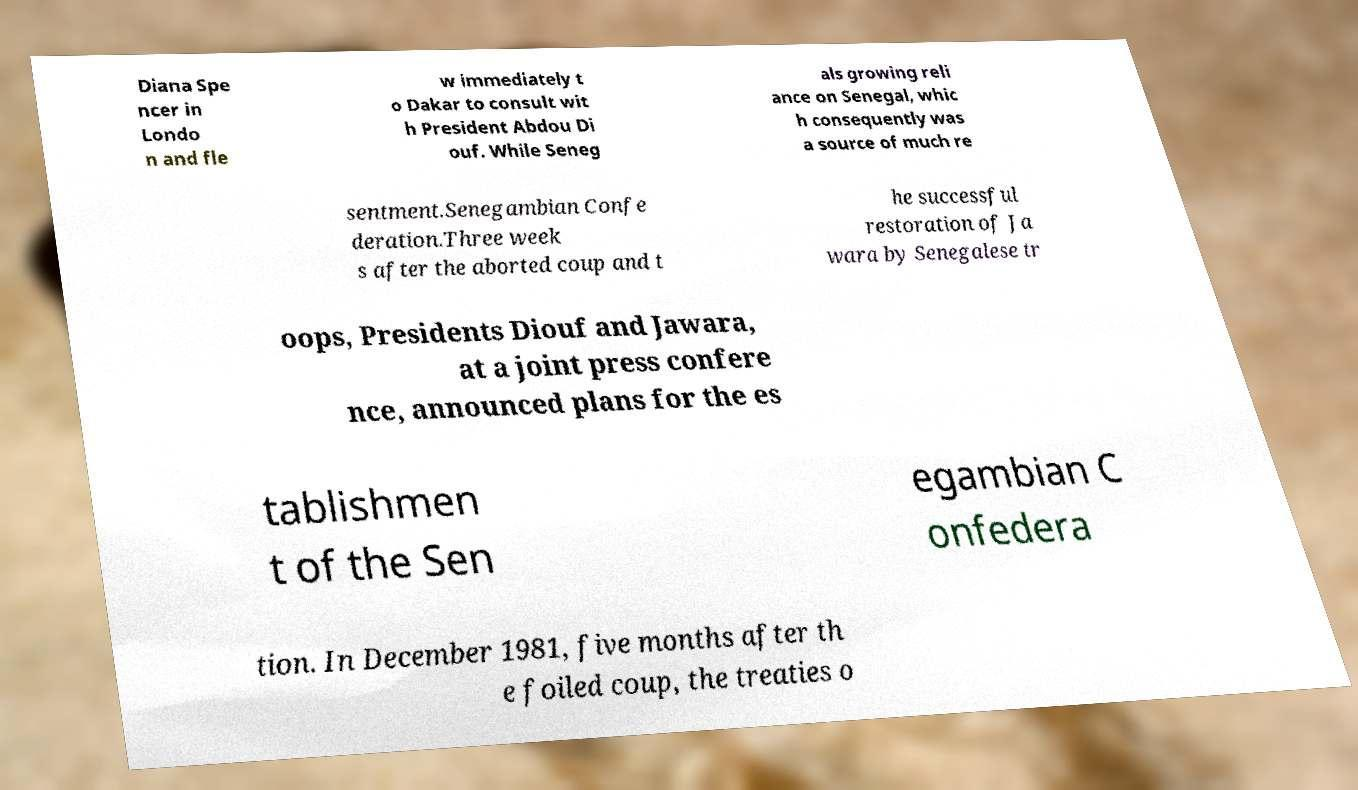For documentation purposes, I need the text within this image transcribed. Could you provide that? Diana Spe ncer in Londo n and fle w immediately t o Dakar to consult wit h President Abdou Di ouf. While Seneg als growing reli ance on Senegal, whic h consequently was a source of much re sentment.Senegambian Confe deration.Three week s after the aborted coup and t he successful restoration of Ja wara by Senegalese tr oops, Presidents Diouf and Jawara, at a joint press confere nce, announced plans for the es tablishmen t of the Sen egambian C onfedera tion. In December 1981, five months after th e foiled coup, the treaties o 